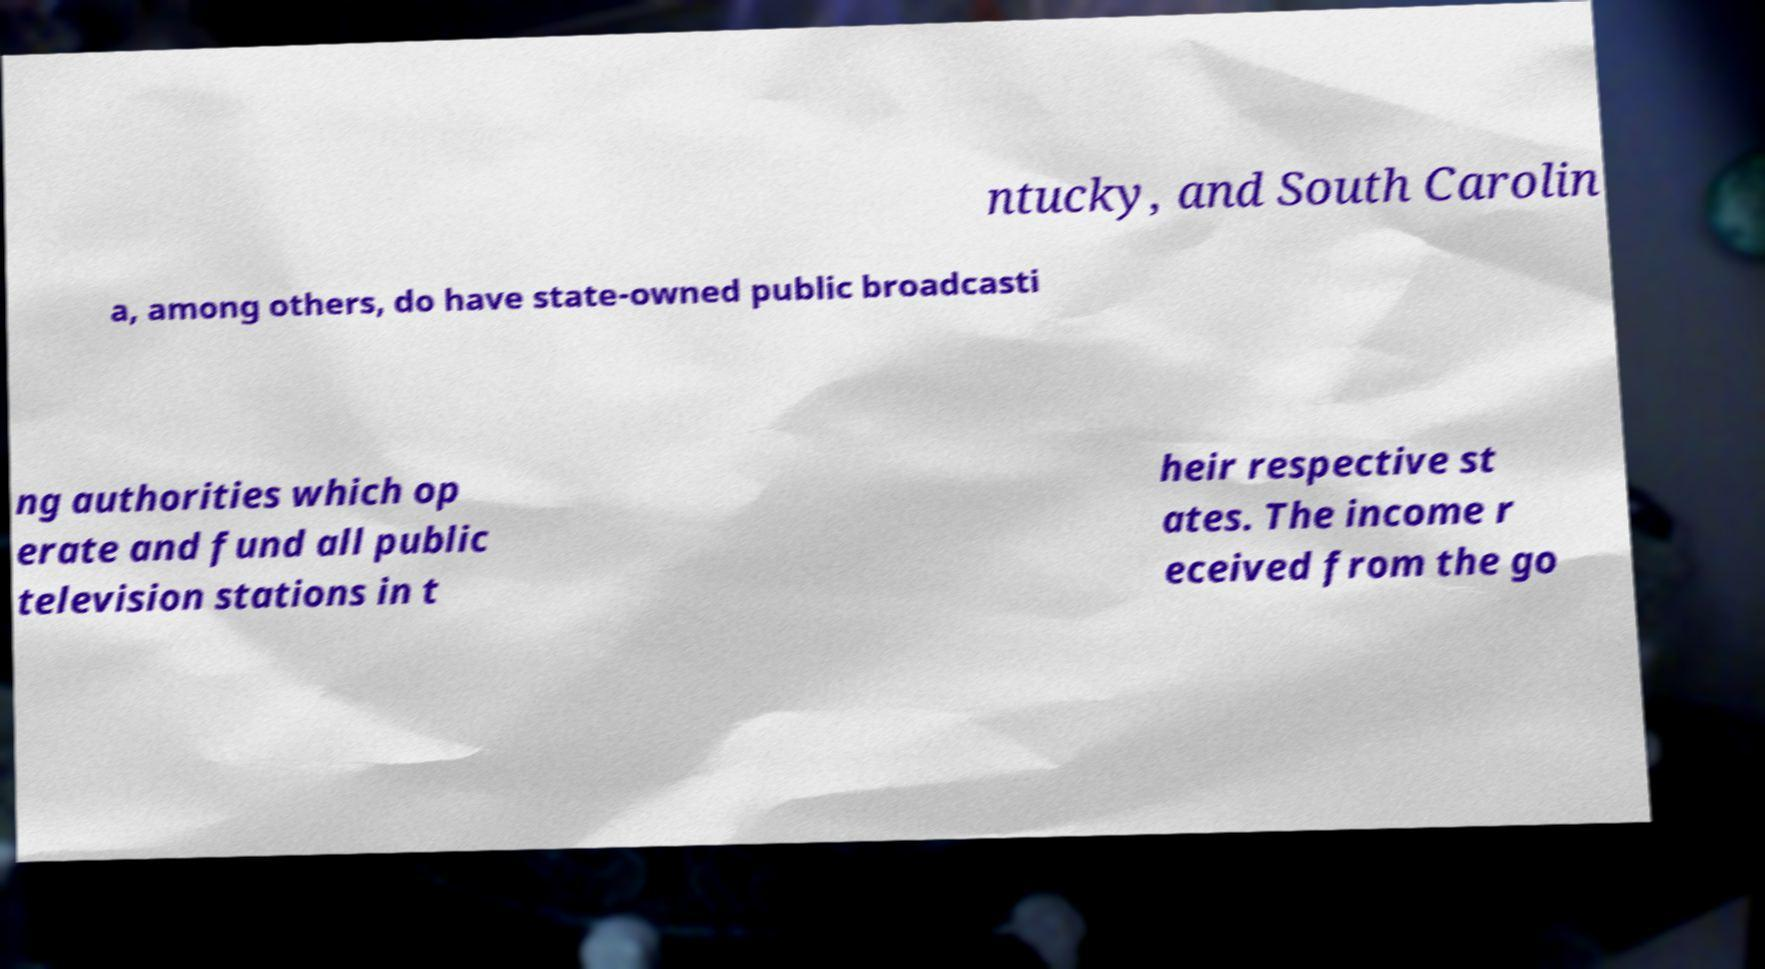There's text embedded in this image that I need extracted. Can you transcribe it verbatim? ntucky, and South Carolin a, among others, do have state-owned public broadcasti ng authorities which op erate and fund all public television stations in t heir respective st ates. The income r eceived from the go 